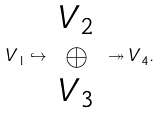Convert formula to latex. <formula><loc_0><loc_0><loc_500><loc_500>V _ { 1 } \hookrightarrow \begin{array} { c } V _ { 2 } \\ \oplus \\ V _ { 3 } \end{array} \twoheadrightarrow V _ { 4 } .</formula> 